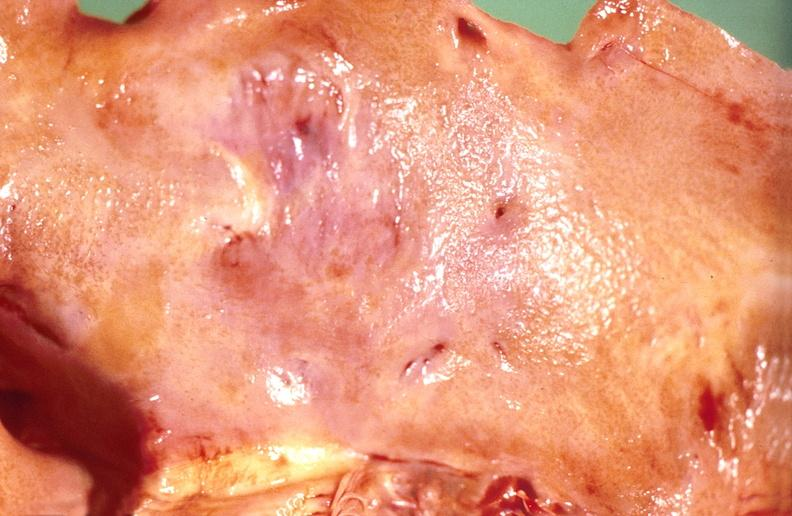does quite good liver show amyloidosis?
Answer the question using a single word or phrase. No 